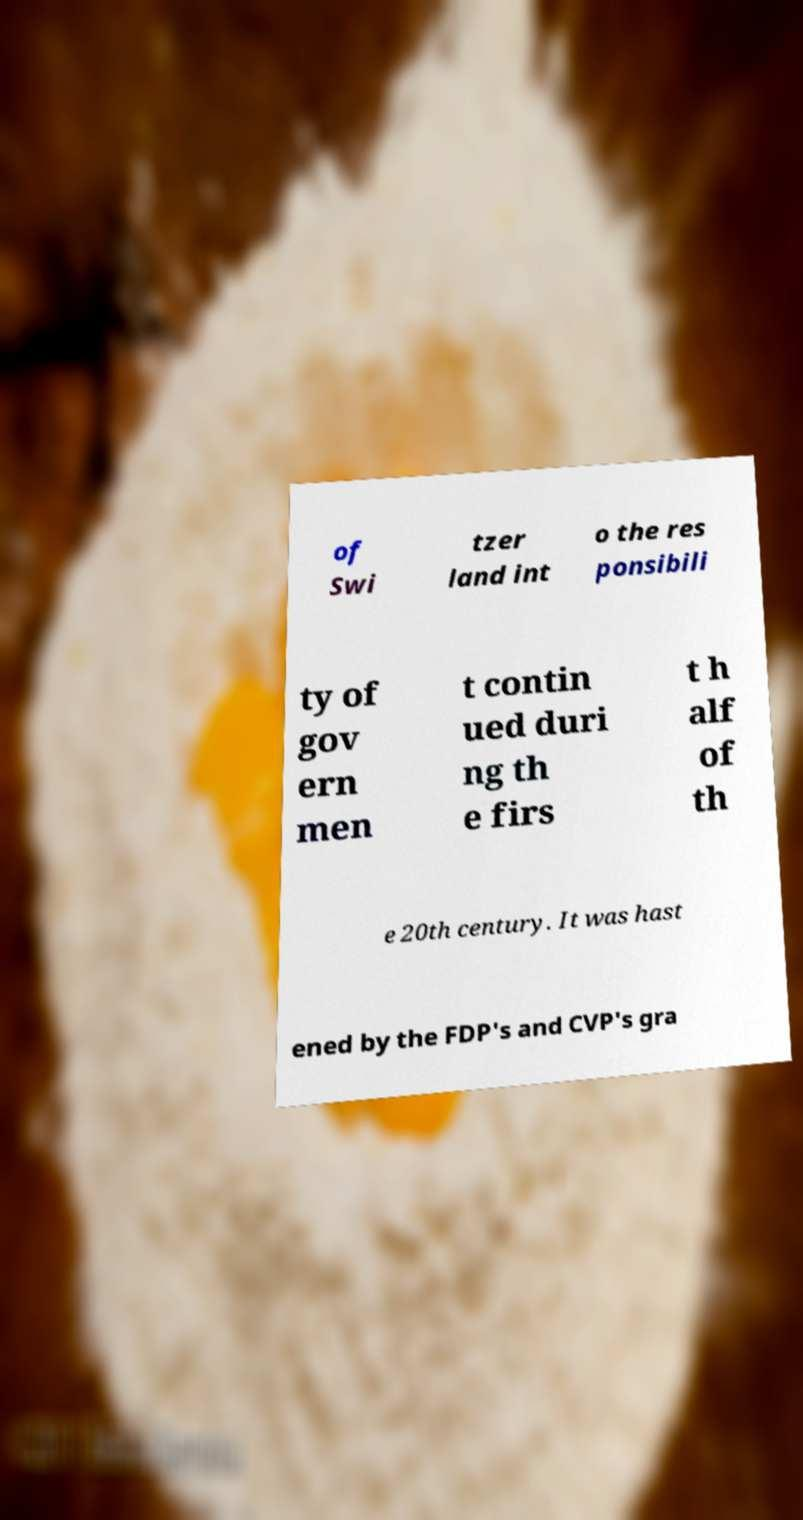Please read and relay the text visible in this image. What does it say? of Swi tzer land int o the res ponsibili ty of gov ern men t contin ued duri ng th e firs t h alf of th e 20th century. It was hast ened by the FDP's and CVP's gra 